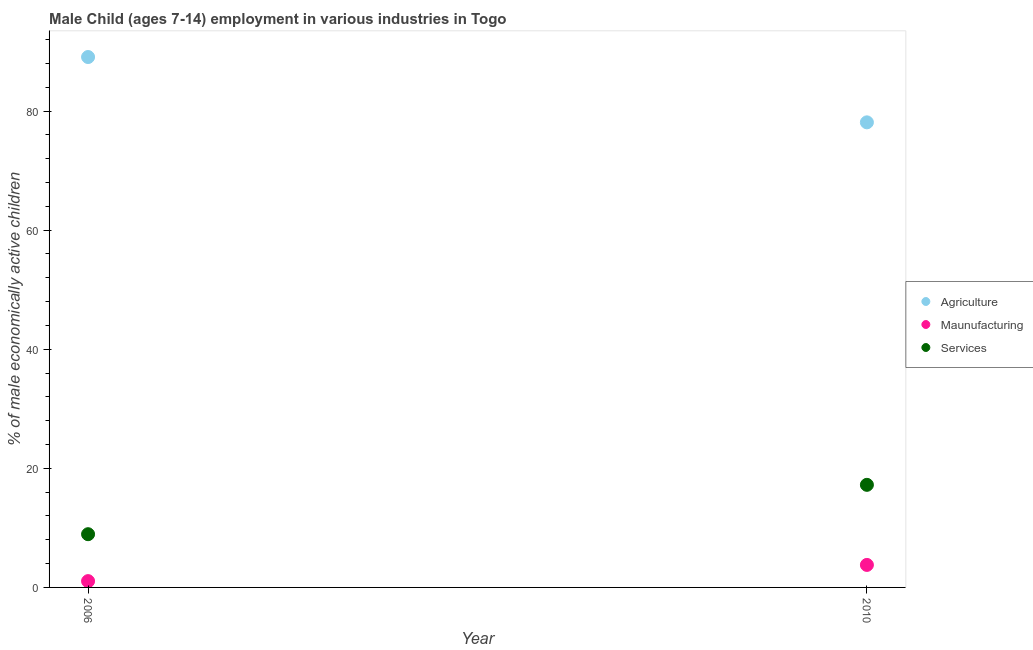Is the number of dotlines equal to the number of legend labels?
Your response must be concise. Yes. What is the percentage of economically active children in agriculture in 2010?
Offer a terse response. 78.11. Across all years, what is the maximum percentage of economically active children in agriculture?
Offer a very short reply. 89.08. Across all years, what is the minimum percentage of economically active children in agriculture?
Offer a terse response. 78.11. In which year was the percentage of economically active children in manufacturing maximum?
Your answer should be very brief. 2010. In which year was the percentage of economically active children in manufacturing minimum?
Provide a succinct answer. 2006. What is the total percentage of economically active children in agriculture in the graph?
Keep it short and to the point. 167.19. What is the difference between the percentage of economically active children in manufacturing in 2006 and that in 2010?
Provide a succinct answer. -2.72. What is the difference between the percentage of economically active children in services in 2010 and the percentage of economically active children in agriculture in 2006?
Provide a short and direct response. -71.85. What is the average percentage of economically active children in agriculture per year?
Make the answer very short. 83.59. In the year 2006, what is the difference between the percentage of economically active children in agriculture and percentage of economically active children in manufacturing?
Give a very brief answer. 88.02. In how many years, is the percentage of economically active children in manufacturing greater than 76 %?
Give a very brief answer. 0. What is the ratio of the percentage of economically active children in agriculture in 2006 to that in 2010?
Offer a very short reply. 1.14. Does the percentage of economically active children in services monotonically increase over the years?
Your answer should be compact. Yes. Is the percentage of economically active children in manufacturing strictly greater than the percentage of economically active children in agriculture over the years?
Your response must be concise. No. Is the percentage of economically active children in manufacturing strictly less than the percentage of economically active children in services over the years?
Give a very brief answer. Yes. Does the graph contain any zero values?
Make the answer very short. No. Where does the legend appear in the graph?
Provide a succinct answer. Center right. How many legend labels are there?
Provide a short and direct response. 3. What is the title of the graph?
Provide a succinct answer. Male Child (ages 7-14) employment in various industries in Togo. What is the label or title of the X-axis?
Offer a very short reply. Year. What is the label or title of the Y-axis?
Offer a very short reply. % of male economically active children. What is the % of male economically active children in Agriculture in 2006?
Make the answer very short. 89.08. What is the % of male economically active children of Maunufacturing in 2006?
Your answer should be compact. 1.06. What is the % of male economically active children of Services in 2006?
Your answer should be very brief. 8.94. What is the % of male economically active children in Agriculture in 2010?
Provide a short and direct response. 78.11. What is the % of male economically active children in Maunufacturing in 2010?
Make the answer very short. 3.78. What is the % of male economically active children of Services in 2010?
Give a very brief answer. 17.23. Across all years, what is the maximum % of male economically active children in Agriculture?
Your answer should be compact. 89.08. Across all years, what is the maximum % of male economically active children in Maunufacturing?
Give a very brief answer. 3.78. Across all years, what is the maximum % of male economically active children in Services?
Make the answer very short. 17.23. Across all years, what is the minimum % of male economically active children of Agriculture?
Ensure brevity in your answer.  78.11. Across all years, what is the minimum % of male economically active children in Maunufacturing?
Your answer should be very brief. 1.06. Across all years, what is the minimum % of male economically active children in Services?
Provide a succinct answer. 8.94. What is the total % of male economically active children of Agriculture in the graph?
Ensure brevity in your answer.  167.19. What is the total % of male economically active children of Maunufacturing in the graph?
Give a very brief answer. 4.84. What is the total % of male economically active children in Services in the graph?
Provide a succinct answer. 26.17. What is the difference between the % of male economically active children of Agriculture in 2006 and that in 2010?
Your response must be concise. 10.97. What is the difference between the % of male economically active children of Maunufacturing in 2006 and that in 2010?
Provide a short and direct response. -2.72. What is the difference between the % of male economically active children of Services in 2006 and that in 2010?
Your answer should be very brief. -8.29. What is the difference between the % of male economically active children of Agriculture in 2006 and the % of male economically active children of Maunufacturing in 2010?
Your response must be concise. 85.3. What is the difference between the % of male economically active children of Agriculture in 2006 and the % of male economically active children of Services in 2010?
Make the answer very short. 71.85. What is the difference between the % of male economically active children in Maunufacturing in 2006 and the % of male economically active children in Services in 2010?
Make the answer very short. -16.17. What is the average % of male economically active children in Agriculture per year?
Offer a very short reply. 83.59. What is the average % of male economically active children in Maunufacturing per year?
Your response must be concise. 2.42. What is the average % of male economically active children in Services per year?
Your answer should be very brief. 13.09. In the year 2006, what is the difference between the % of male economically active children of Agriculture and % of male economically active children of Maunufacturing?
Your answer should be compact. 88.02. In the year 2006, what is the difference between the % of male economically active children of Agriculture and % of male economically active children of Services?
Ensure brevity in your answer.  80.14. In the year 2006, what is the difference between the % of male economically active children of Maunufacturing and % of male economically active children of Services?
Give a very brief answer. -7.88. In the year 2010, what is the difference between the % of male economically active children of Agriculture and % of male economically active children of Maunufacturing?
Offer a very short reply. 74.33. In the year 2010, what is the difference between the % of male economically active children of Agriculture and % of male economically active children of Services?
Offer a terse response. 60.88. In the year 2010, what is the difference between the % of male economically active children of Maunufacturing and % of male economically active children of Services?
Ensure brevity in your answer.  -13.45. What is the ratio of the % of male economically active children of Agriculture in 2006 to that in 2010?
Your answer should be compact. 1.14. What is the ratio of the % of male economically active children in Maunufacturing in 2006 to that in 2010?
Your answer should be very brief. 0.28. What is the ratio of the % of male economically active children of Services in 2006 to that in 2010?
Your response must be concise. 0.52. What is the difference between the highest and the second highest % of male economically active children of Agriculture?
Your answer should be compact. 10.97. What is the difference between the highest and the second highest % of male economically active children of Maunufacturing?
Give a very brief answer. 2.72. What is the difference between the highest and the second highest % of male economically active children in Services?
Provide a succinct answer. 8.29. What is the difference between the highest and the lowest % of male economically active children in Agriculture?
Make the answer very short. 10.97. What is the difference between the highest and the lowest % of male economically active children in Maunufacturing?
Offer a very short reply. 2.72. What is the difference between the highest and the lowest % of male economically active children in Services?
Make the answer very short. 8.29. 